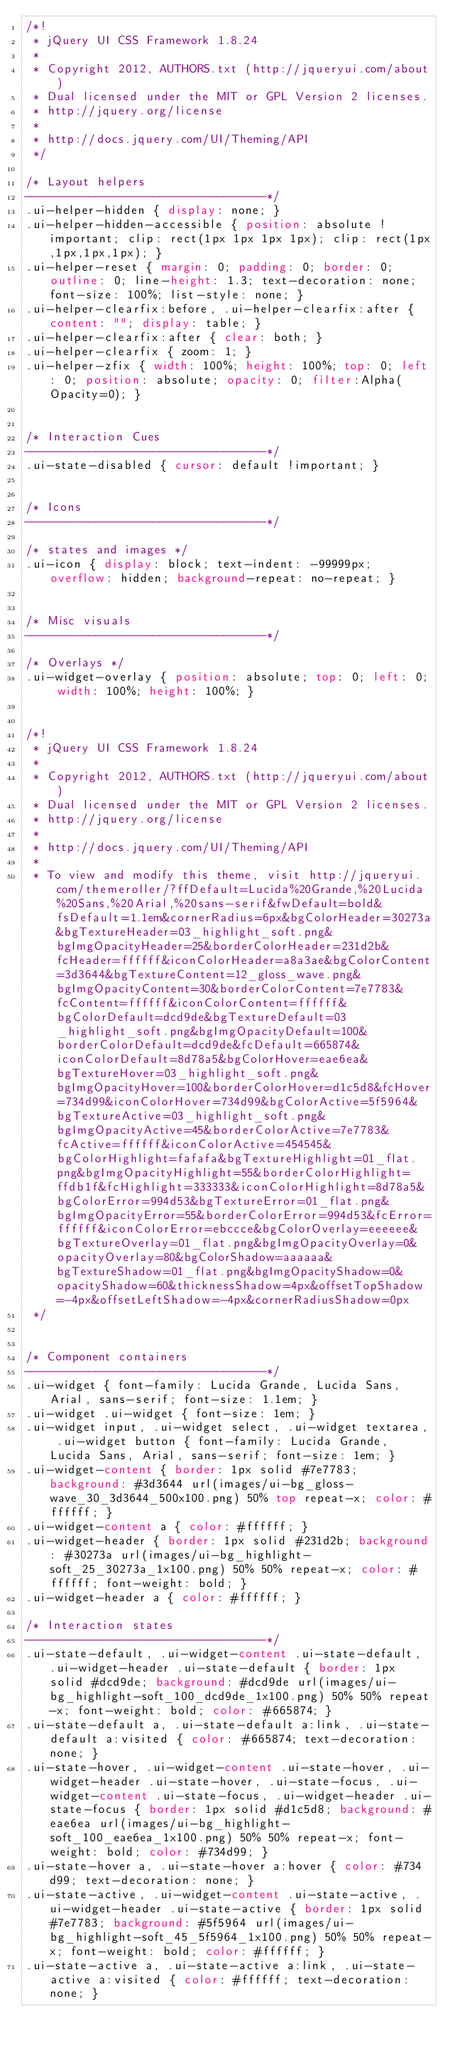Convert code to text. <code><loc_0><loc_0><loc_500><loc_500><_CSS_>/*!
 * jQuery UI CSS Framework 1.8.24
 *
 * Copyright 2012, AUTHORS.txt (http://jqueryui.com/about)
 * Dual licensed under the MIT or GPL Version 2 licenses.
 * http://jquery.org/license
 *
 * http://docs.jquery.com/UI/Theming/API
 */

/* Layout helpers
----------------------------------*/
.ui-helper-hidden { display: none; }
.ui-helper-hidden-accessible { position: absolute !important; clip: rect(1px 1px 1px 1px); clip: rect(1px,1px,1px,1px); }
.ui-helper-reset { margin: 0; padding: 0; border: 0; outline: 0; line-height: 1.3; text-decoration: none; font-size: 100%; list-style: none; }
.ui-helper-clearfix:before, .ui-helper-clearfix:after { content: ""; display: table; }
.ui-helper-clearfix:after { clear: both; }
.ui-helper-clearfix { zoom: 1; }
.ui-helper-zfix { width: 100%; height: 100%; top: 0; left: 0; position: absolute; opacity: 0; filter:Alpha(Opacity=0); }


/* Interaction Cues
----------------------------------*/
.ui-state-disabled { cursor: default !important; }


/* Icons
----------------------------------*/

/* states and images */
.ui-icon { display: block; text-indent: -99999px; overflow: hidden; background-repeat: no-repeat; }


/* Misc visuals
----------------------------------*/

/* Overlays */
.ui-widget-overlay { position: absolute; top: 0; left: 0; width: 100%; height: 100%; }


/*!
 * jQuery UI CSS Framework 1.8.24
 *
 * Copyright 2012, AUTHORS.txt (http://jqueryui.com/about)
 * Dual licensed under the MIT or GPL Version 2 licenses.
 * http://jquery.org/license
 *
 * http://docs.jquery.com/UI/Theming/API
 *
 * To view and modify this theme, visit http://jqueryui.com/themeroller/?ffDefault=Lucida%20Grande,%20Lucida%20Sans,%20Arial,%20sans-serif&fwDefault=bold&fsDefault=1.1em&cornerRadius=6px&bgColorHeader=30273a&bgTextureHeader=03_highlight_soft.png&bgImgOpacityHeader=25&borderColorHeader=231d2b&fcHeader=ffffff&iconColorHeader=a8a3ae&bgColorContent=3d3644&bgTextureContent=12_gloss_wave.png&bgImgOpacityContent=30&borderColorContent=7e7783&fcContent=ffffff&iconColorContent=ffffff&bgColorDefault=dcd9de&bgTextureDefault=03_highlight_soft.png&bgImgOpacityDefault=100&borderColorDefault=dcd9de&fcDefault=665874&iconColorDefault=8d78a5&bgColorHover=eae6ea&bgTextureHover=03_highlight_soft.png&bgImgOpacityHover=100&borderColorHover=d1c5d8&fcHover=734d99&iconColorHover=734d99&bgColorActive=5f5964&bgTextureActive=03_highlight_soft.png&bgImgOpacityActive=45&borderColorActive=7e7783&fcActive=ffffff&iconColorActive=454545&bgColorHighlight=fafafa&bgTextureHighlight=01_flat.png&bgImgOpacityHighlight=55&borderColorHighlight=ffdb1f&fcHighlight=333333&iconColorHighlight=8d78a5&bgColorError=994d53&bgTextureError=01_flat.png&bgImgOpacityError=55&borderColorError=994d53&fcError=ffffff&iconColorError=ebccce&bgColorOverlay=eeeeee&bgTextureOverlay=01_flat.png&bgImgOpacityOverlay=0&opacityOverlay=80&bgColorShadow=aaaaaa&bgTextureShadow=01_flat.png&bgImgOpacityShadow=0&opacityShadow=60&thicknessShadow=4px&offsetTopShadow=-4px&offsetLeftShadow=-4px&cornerRadiusShadow=0px
 */


/* Component containers
----------------------------------*/
.ui-widget { font-family: Lucida Grande, Lucida Sans, Arial, sans-serif; font-size: 1.1em; }
.ui-widget .ui-widget { font-size: 1em; }
.ui-widget input, .ui-widget select, .ui-widget textarea, .ui-widget button { font-family: Lucida Grande, Lucida Sans, Arial, sans-serif; font-size: 1em; }
.ui-widget-content { border: 1px solid #7e7783; background: #3d3644 url(images/ui-bg_gloss-wave_30_3d3644_500x100.png) 50% top repeat-x; color: #ffffff; }
.ui-widget-content a { color: #ffffff; }
.ui-widget-header { border: 1px solid #231d2b; background: #30273a url(images/ui-bg_highlight-soft_25_30273a_1x100.png) 50% 50% repeat-x; color: #ffffff; font-weight: bold; }
.ui-widget-header a { color: #ffffff; }

/* Interaction states
----------------------------------*/
.ui-state-default, .ui-widget-content .ui-state-default, .ui-widget-header .ui-state-default { border: 1px solid #dcd9de; background: #dcd9de url(images/ui-bg_highlight-soft_100_dcd9de_1x100.png) 50% 50% repeat-x; font-weight: bold; color: #665874; }
.ui-state-default a, .ui-state-default a:link, .ui-state-default a:visited { color: #665874; text-decoration: none; }
.ui-state-hover, .ui-widget-content .ui-state-hover, .ui-widget-header .ui-state-hover, .ui-state-focus, .ui-widget-content .ui-state-focus, .ui-widget-header .ui-state-focus { border: 1px solid #d1c5d8; background: #eae6ea url(images/ui-bg_highlight-soft_100_eae6ea_1x100.png) 50% 50% repeat-x; font-weight: bold; color: #734d99; }
.ui-state-hover a, .ui-state-hover a:hover { color: #734d99; text-decoration: none; }
.ui-state-active, .ui-widget-content .ui-state-active, .ui-widget-header .ui-state-active { border: 1px solid #7e7783; background: #5f5964 url(images/ui-bg_highlight-soft_45_5f5964_1x100.png) 50% 50% repeat-x; font-weight: bold; color: #ffffff; }
.ui-state-active a, .ui-state-active a:link, .ui-state-active a:visited { color: #ffffff; text-decoration: none; }</code> 